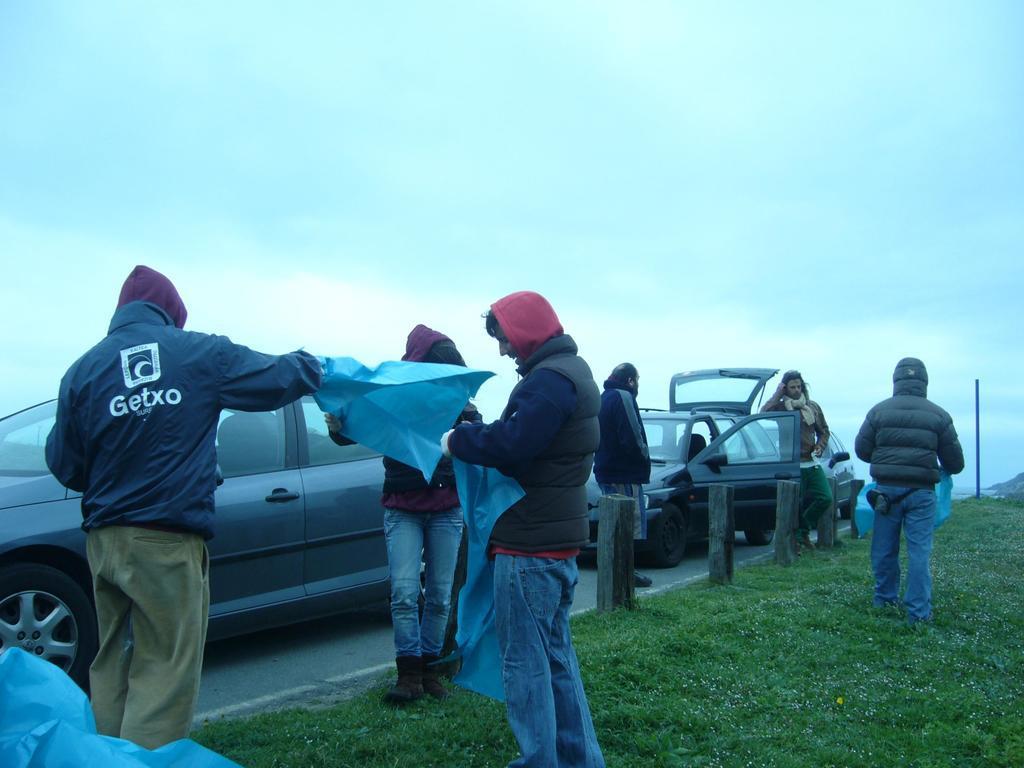Could you give a brief overview of what you see in this image? In the background we can see the sky. In this picture we can see the cars, road, poles and green grass. We can see the people and few are holding blue cover sheets. 